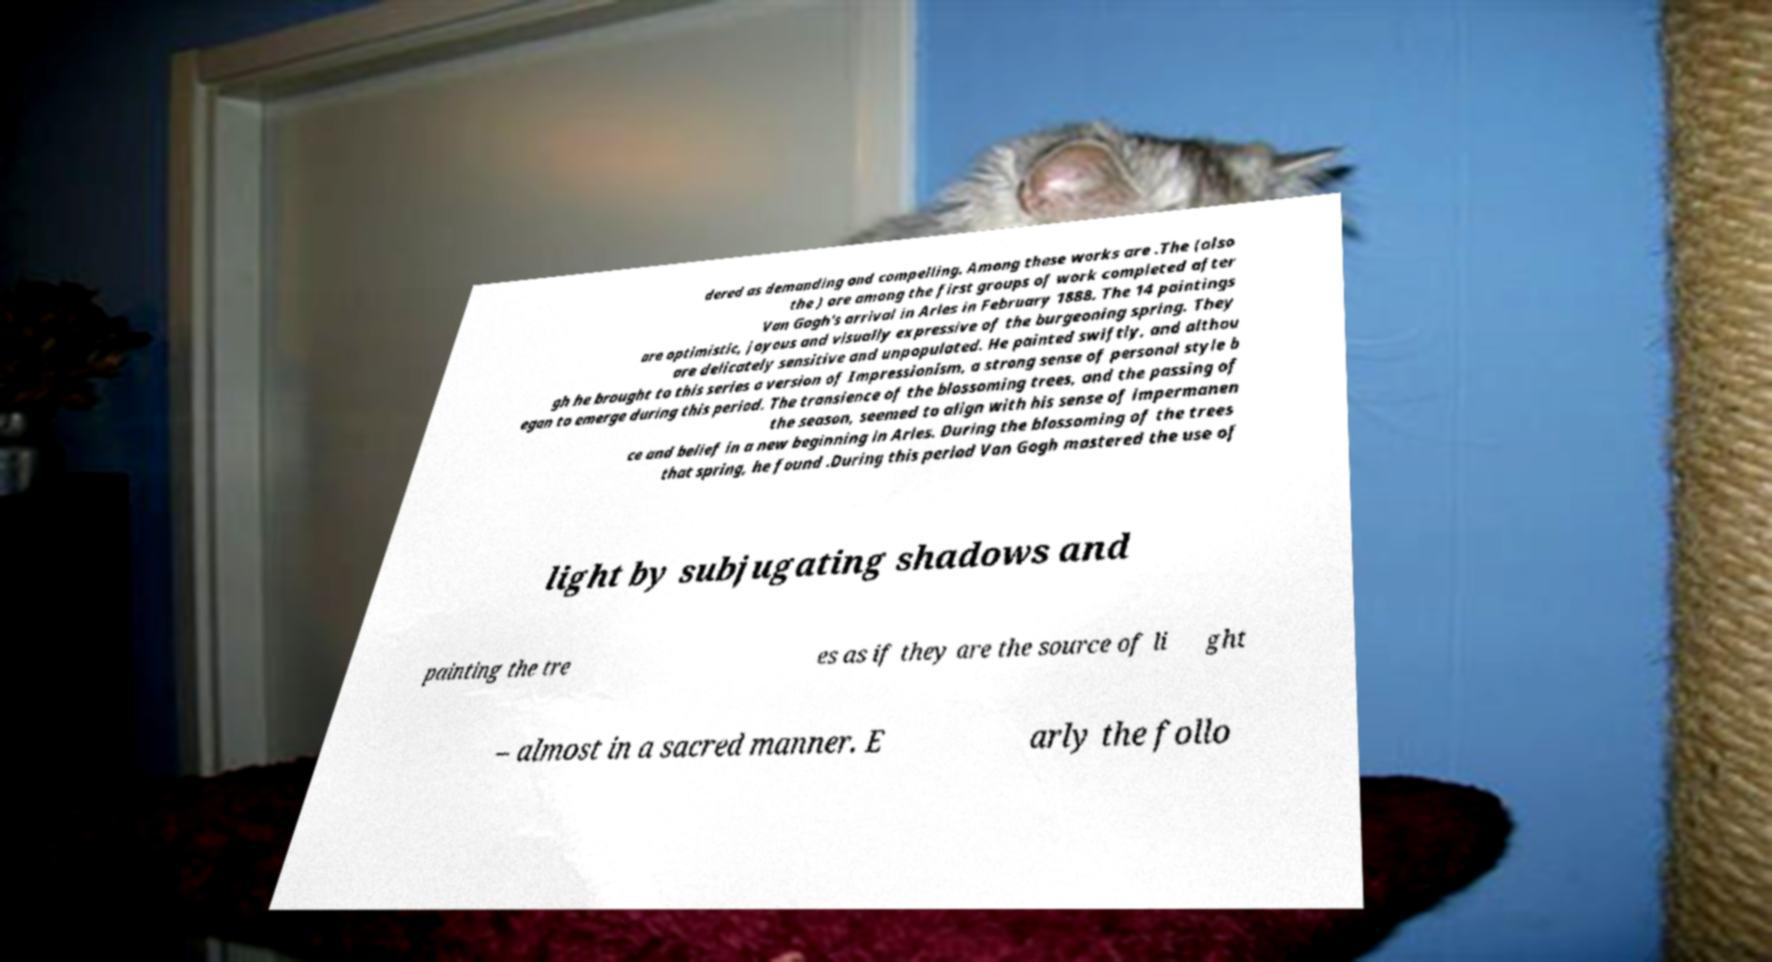Can you read and provide the text displayed in the image?This photo seems to have some interesting text. Can you extract and type it out for me? dered as demanding and compelling. Among these works are .The (also the ) are among the first groups of work completed after Van Gogh's arrival in Arles in February 1888. The 14 paintings are optimistic, joyous and visually expressive of the burgeoning spring. They are delicately sensitive and unpopulated. He painted swiftly, and althou gh he brought to this series a version of Impressionism, a strong sense of personal style b egan to emerge during this period. The transience of the blossoming trees, and the passing of the season, seemed to align with his sense of impermanen ce and belief in a new beginning in Arles. During the blossoming of the trees that spring, he found .During this period Van Gogh mastered the use of light by subjugating shadows and painting the tre es as if they are the source of li ght – almost in a sacred manner. E arly the follo 